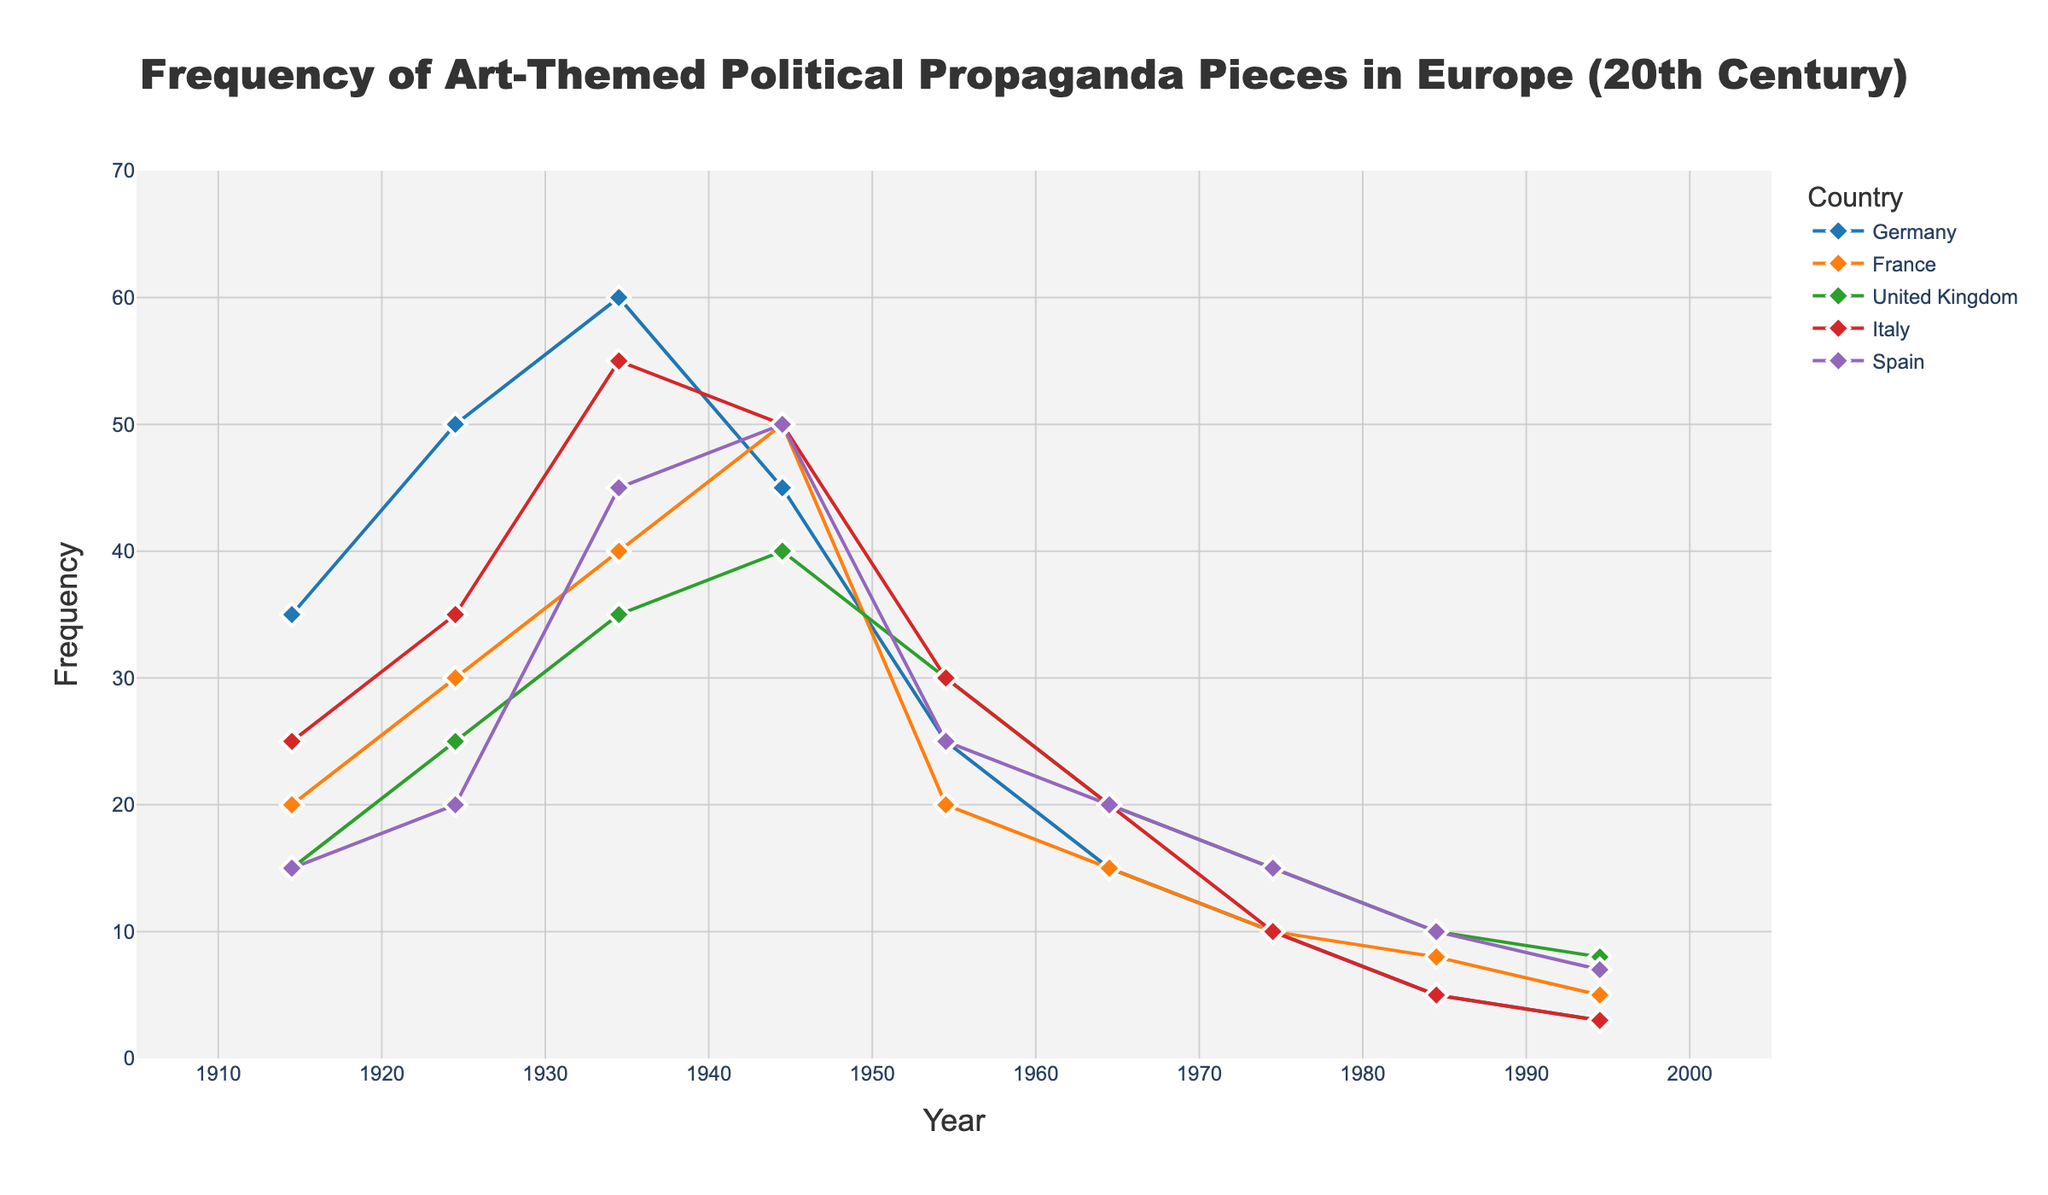What is the title of the figure? The title of a figure is usually placed at the top, centered, and distinct in size and font to make it easily identifiable. Here, it can be found in a larger font size at the top of the plot.
Answer: Frequency of Art-Themed Political Propaganda Pieces in Europe (20th Century) Which country had the highest frequency of art-themed political propaganda pieces in the 1930s? Each country's mid-decade values and frequencies are plotted. By examining around 1935, the data points and colors indicate that Germany had the highest frequency.
Answer: Germany What is the median frequency of art-themed political propaganda pieces in Germany? List the frequencies for Germany (35, 50, 60, 45, 25, 15, 10, 5, 3), and sort them (3, 5, 10, 15, 25, 35, 45, 50, 60). The median is the middle value.
Answer: 25 During which decade did France see the highest frequency of art-themed political propaganda pieces? By looking at the curve for France and locating the highest point, it is clear that the peak occurs in the 1940s.
Answer: 1940s How does the frequency of art-themed political propaganda pieces in Spain in the 1960s compare to Italy in the same period? The plot points for both Spain and Italy in the 1960s can be compared by looking at the values around 1965. Spain and Italy both have a frequency of 20.
Answer: Equal Calculate the average frequency of art-themed political propaganda pieces in the United Kingdom across all decades shown. Add the frequencies for the United Kingdom (15, 25, 35, 40, 30, 20, 15, 10, 8) and divide by the number of decades (9). The sum is 198, so the average is 198/9.
Answer: 22 Which country experienced the steepest decline in frequency from its peak to the end of the century? Examine each country's peak and its lowest point at the end of the century. Calculate the difference. Germany goes from 60 to 3 (a decline of 57), which is the steepest.
Answer: Germany Which two countries had an equal frequency of art-themed political propaganda pieces in the 1940s? Comparing the values for each country in the 1940s, Germany and Spain both have a frequency of 50.
Answer: Germany and Spain In which decade did the frequency of art-themed political propaganda pieces begin to decrease in Germany? Observing the trend line for Germany, the frequency decreases beginning from the 1930s to the 1940s.
Answer: 1940s 